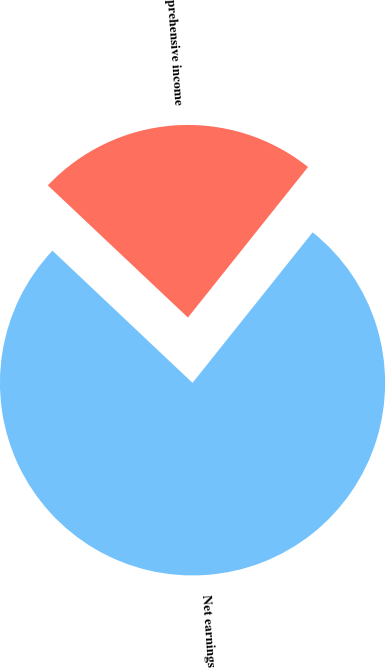Convert chart to OTSL. <chart><loc_0><loc_0><loc_500><loc_500><pie_chart><fcel>Net earnings<fcel>Comprehensive income<nl><fcel>76.32%<fcel>23.68%<nl></chart> 